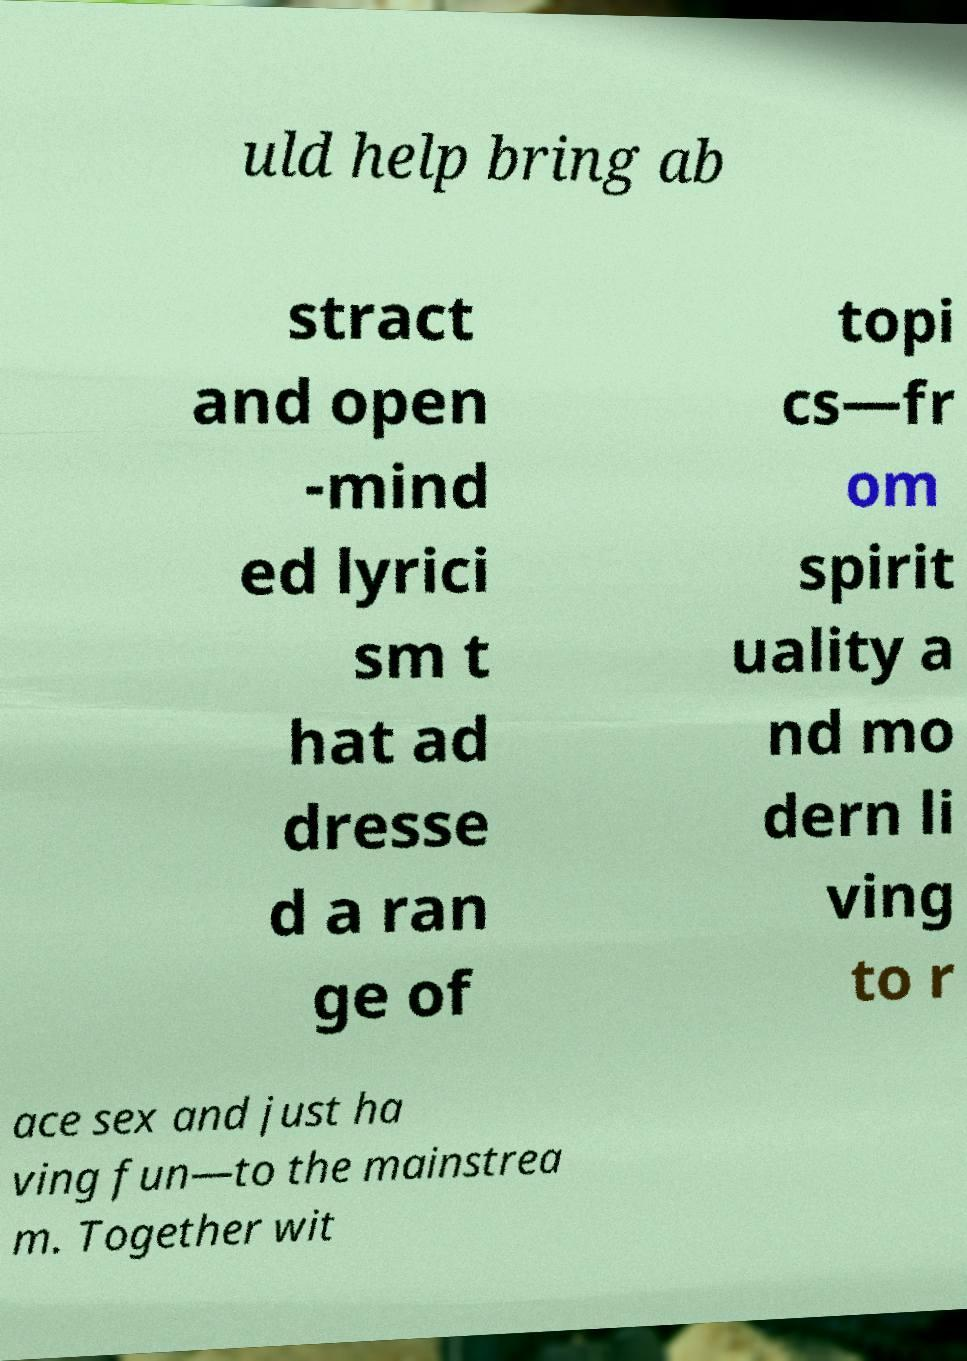Could you assist in decoding the text presented in this image and type it out clearly? uld help bring ab stract and open -mind ed lyrici sm t hat ad dresse d a ran ge of topi cs—fr om spirit uality a nd mo dern li ving to r ace sex and just ha ving fun—to the mainstrea m. Together wit 